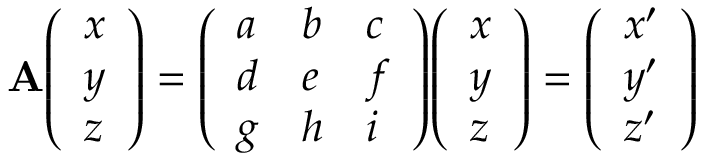Convert formula to latex. <formula><loc_0><loc_0><loc_500><loc_500>A { \left ( \begin{array} { l } { x } \\ { y } \\ { z } \end{array} \right ) } = { \left ( \begin{array} { l l l } { a } & { b } & { c } \\ { d } & { e } & { f } \\ { g } & { h } & { i } \end{array} \right ) } { \left ( \begin{array} { l } { x } \\ { y } \\ { z } \end{array} \right ) } = { \left ( \begin{array} { l } { x ^ { \prime } } \\ { y ^ { \prime } } \\ { z ^ { \prime } } \end{array} \right ) }</formula> 